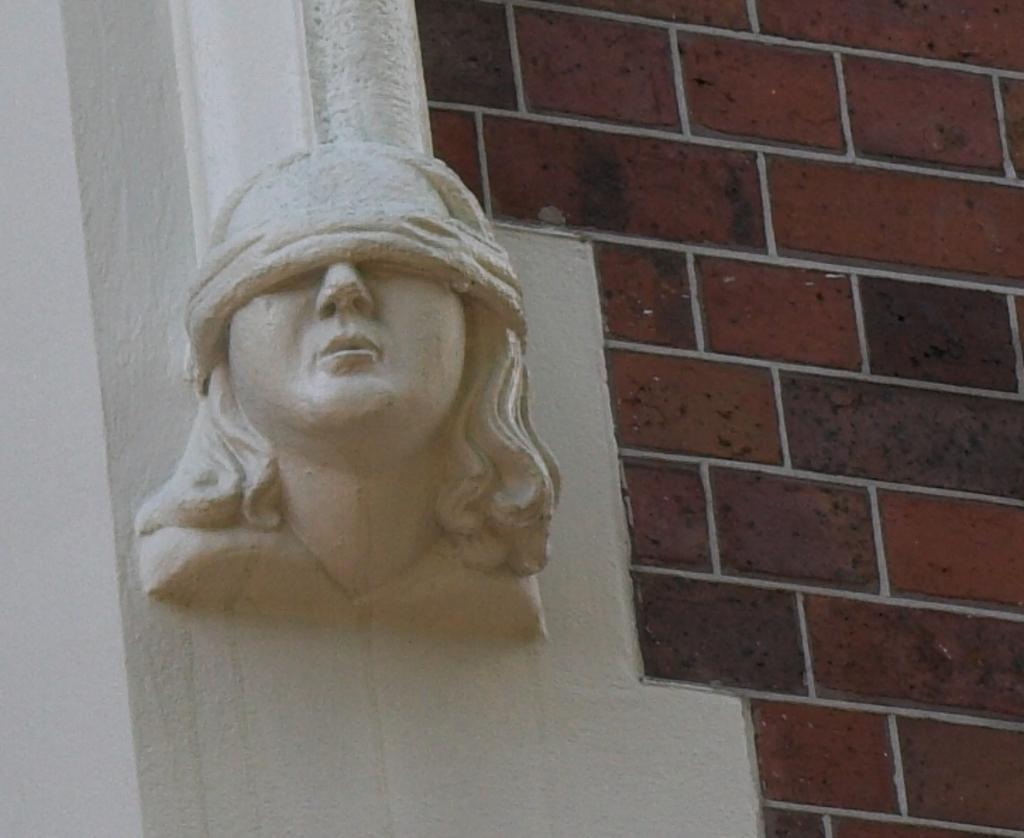What is the main subject of the image? There is a sculpture in the image. What type of background is present in the image? There is a brick wall in the image. What type of chair can be seen in the image? There is no chair present in the image; it only features a sculpture and a brick wall. What is the texture of the sculpture in the image? The provided facts do not mention the texture of the sculpture, so it cannot be determined from the image. 